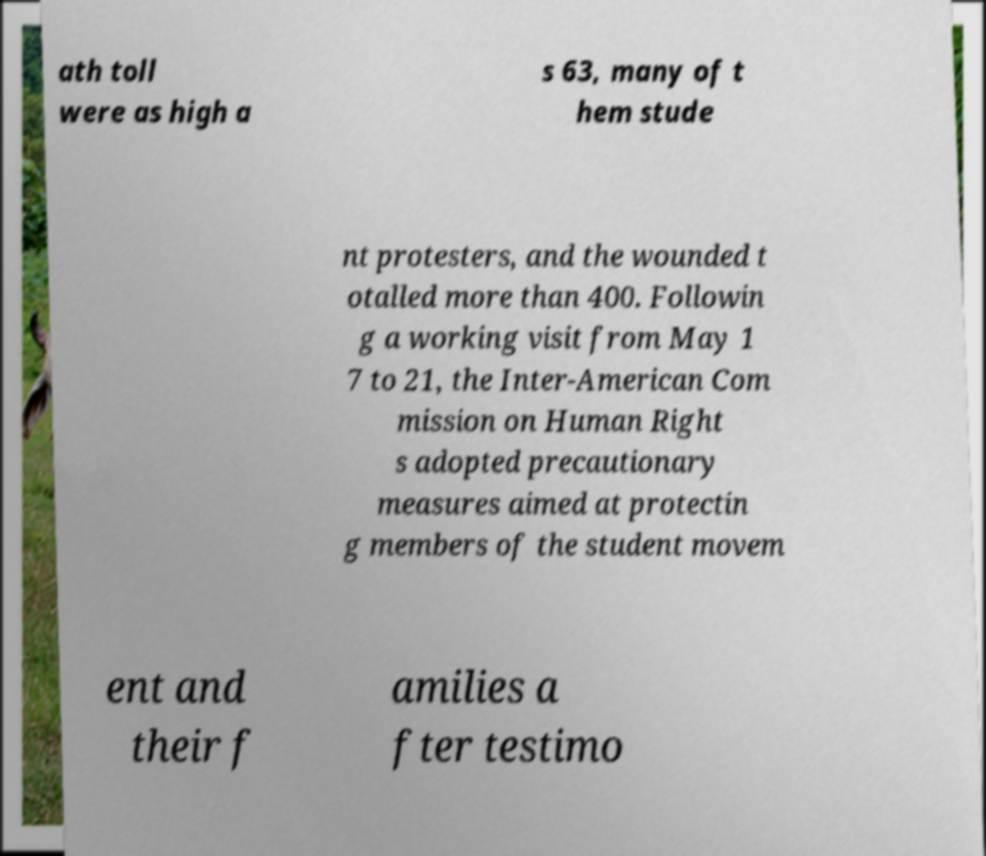Can you accurately transcribe the text from the provided image for me? ath toll were as high a s 63, many of t hem stude nt protesters, and the wounded t otalled more than 400. Followin g a working visit from May 1 7 to 21, the Inter-American Com mission on Human Right s adopted precautionary measures aimed at protectin g members of the student movem ent and their f amilies a fter testimo 